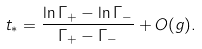<formula> <loc_0><loc_0><loc_500><loc_500>t _ { \ast } = \frac { \ln \Gamma _ { + } - \ln \Gamma _ { - } } { \Gamma _ { + } - \Gamma _ { - } } + O ( g ) .</formula> 